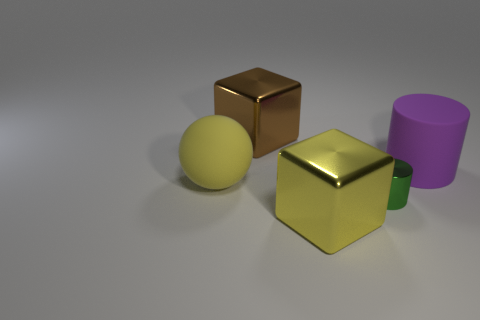Add 3 tiny green metal things. How many objects exist? 8 Subtract all brown cubes. How many cubes are left? 1 Subtract all cubes. How many objects are left? 3 Subtract all red balls. Subtract all brown cylinders. How many balls are left? 1 Subtract all yellow matte cylinders. Subtract all cubes. How many objects are left? 3 Add 5 green cylinders. How many green cylinders are left? 6 Add 2 small purple objects. How many small purple objects exist? 2 Subtract 0 blue spheres. How many objects are left? 5 